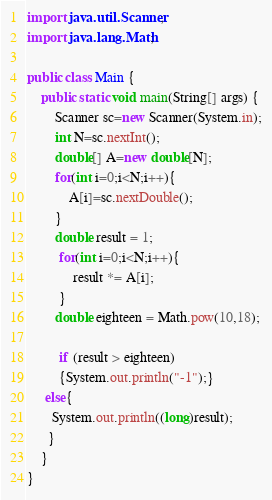Convert code to text. <code><loc_0><loc_0><loc_500><loc_500><_Java_>import java.util.Scanner;
import java.lang.Math;
 
public class Main {
    public static void main(String[] args) {
        Scanner sc=new Scanner(System.in);
        int N=sc.nextInt();
        double[] A=new double[N];
        for(int i=0;i<N;i++){
            A[i]=sc.nextDouble();
        }
		double result = 1;
		 for(int i=0;i<N;i++){
			 result *= A[i];
		 }
        double eighteen = Math.pow(10,18);

		 if (result > eighteen)
		 {System.out.println("-1");}
	 else{
       System.out.println((long)result);
      }
    }
}</code> 